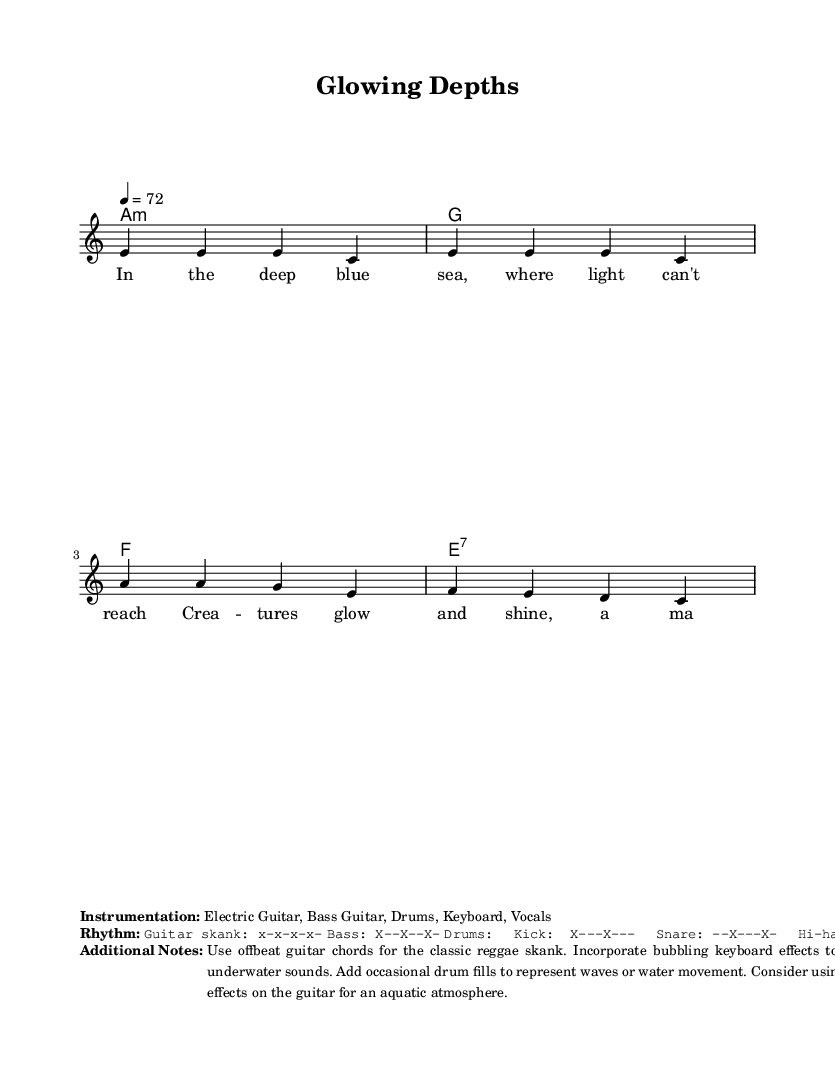What is the key signature of this music? The key signature is A minor, which has one sharp (G#). The presence of the 'a' in 'a:m' indicates the key.
Answer: A minor What is the time signature of this music? The time signature is 4/4, as indicated in the score. It specifies that there are four beats in each measure.
Answer: 4/4 What is the tempo marking of this music? The tempo marking is 72 beats per minute, as indicated in the score with the notation "4 = 72."
Answer: 72 What is the main theme of the lyrics? The lyrics describe bioluminescent marine creatures that glow and shine in the deep sea. The wonder of these glowing creatures is emphasized in the text.
Answer: Glowing creatures What instruments are used in this piece? The list of instruments includes Electric Guitar, Bass Guitar, Drums, Keyboard, and Vocals. This information is noted under the instrumentation section in the score.
Answer: Electric Guitar, Bass Guitar, Drums, Keyboard, Vocals What type of rhythm pattern is specified for the guitar? The guitar rhythm pattern is described as "x-x-x-x-," indicating an offbeat strumming pattern typical in reggae music. This information is included in the rhythm section of the score.
Answer: x-x-x-x- What musical genre does this piece belong to? This piece belongs to the reggae genre, as indicated in the context and characteristics of the music structure and rhythm.
Answer: Reggae 